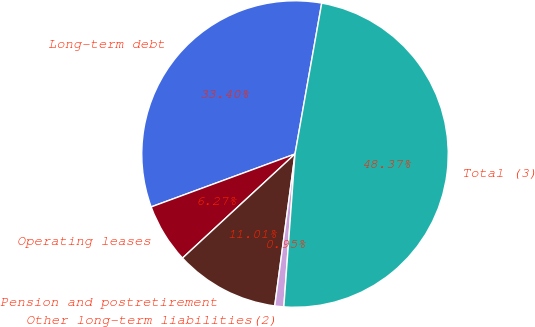<chart> <loc_0><loc_0><loc_500><loc_500><pie_chart><fcel>Long-term debt<fcel>Operating leases<fcel>Pension and postretirement<fcel>Other long-term liabilities(2)<fcel>Total (3)<nl><fcel>33.4%<fcel>6.27%<fcel>11.01%<fcel>0.95%<fcel>48.37%<nl></chart> 